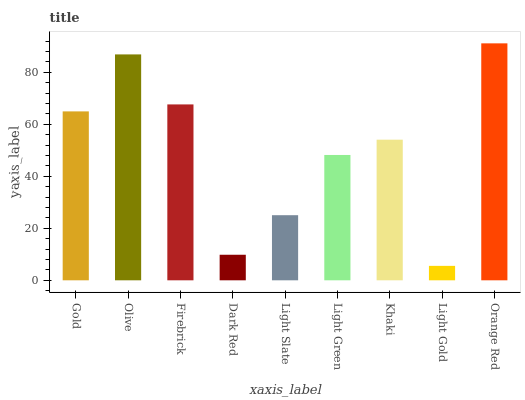Is Light Gold the minimum?
Answer yes or no. Yes. Is Orange Red the maximum?
Answer yes or no. Yes. Is Olive the minimum?
Answer yes or no. No. Is Olive the maximum?
Answer yes or no. No. Is Olive greater than Gold?
Answer yes or no. Yes. Is Gold less than Olive?
Answer yes or no. Yes. Is Gold greater than Olive?
Answer yes or no. No. Is Olive less than Gold?
Answer yes or no. No. Is Khaki the high median?
Answer yes or no. Yes. Is Khaki the low median?
Answer yes or no. Yes. Is Light Gold the high median?
Answer yes or no. No. Is Dark Red the low median?
Answer yes or no. No. 